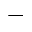Convert formula to latex. <formula><loc_0><loc_0><loc_500><loc_500>^ { - }</formula> 